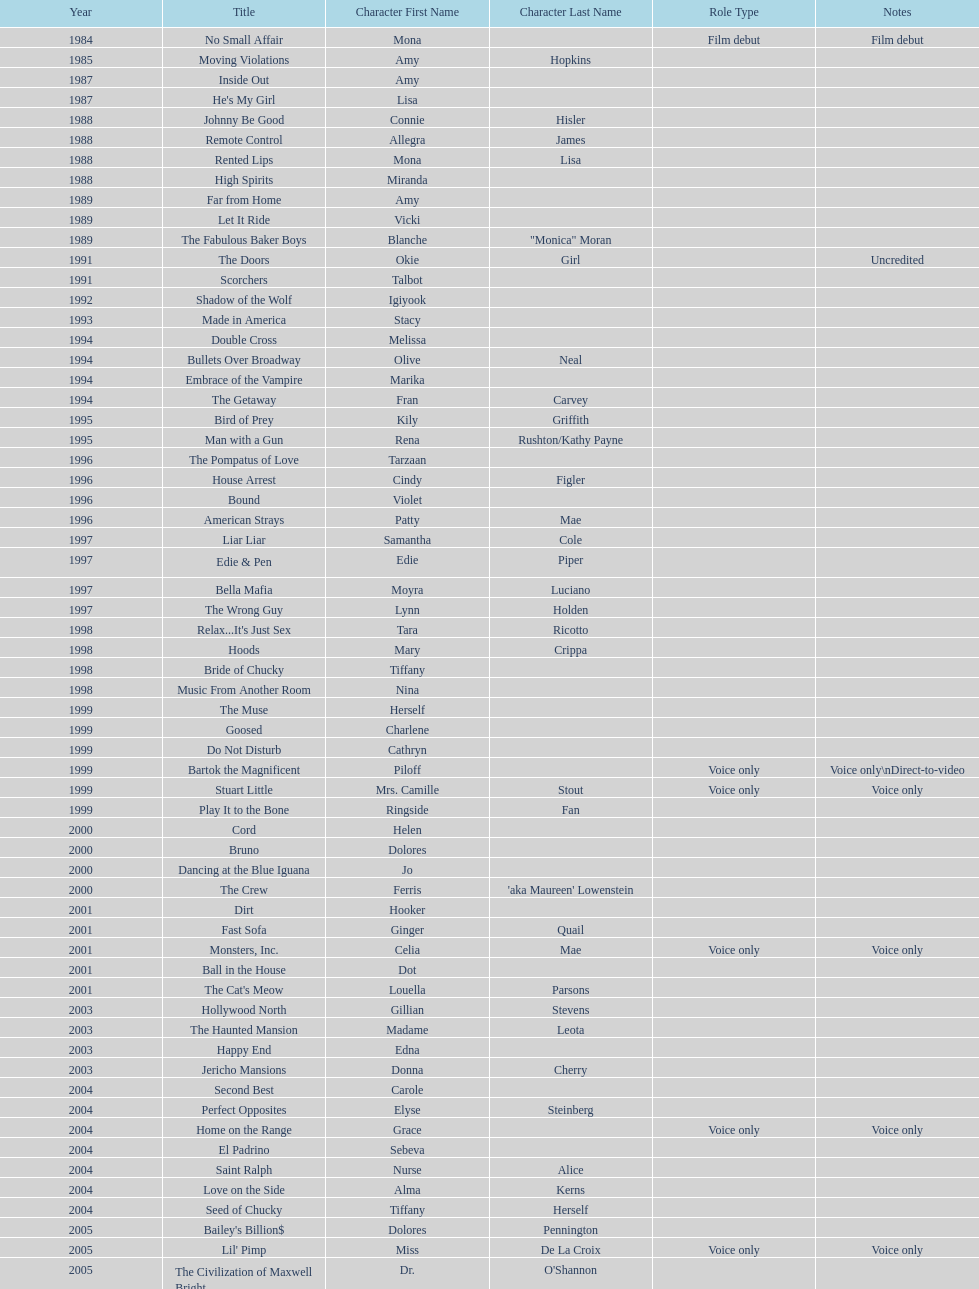Which film aired in 1994 and has marika as the role? Embrace of the Vampire. 